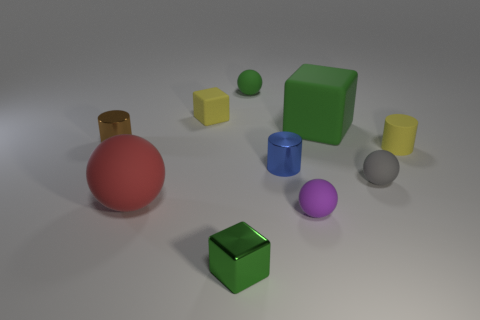Subtract all blocks. How many objects are left? 7 Add 8 gray rubber objects. How many gray rubber objects exist? 9 Subtract 0 cyan cylinders. How many objects are left? 10 Subtract all yellow matte things. Subtract all yellow cylinders. How many objects are left? 7 Add 3 small purple balls. How many small purple balls are left? 4 